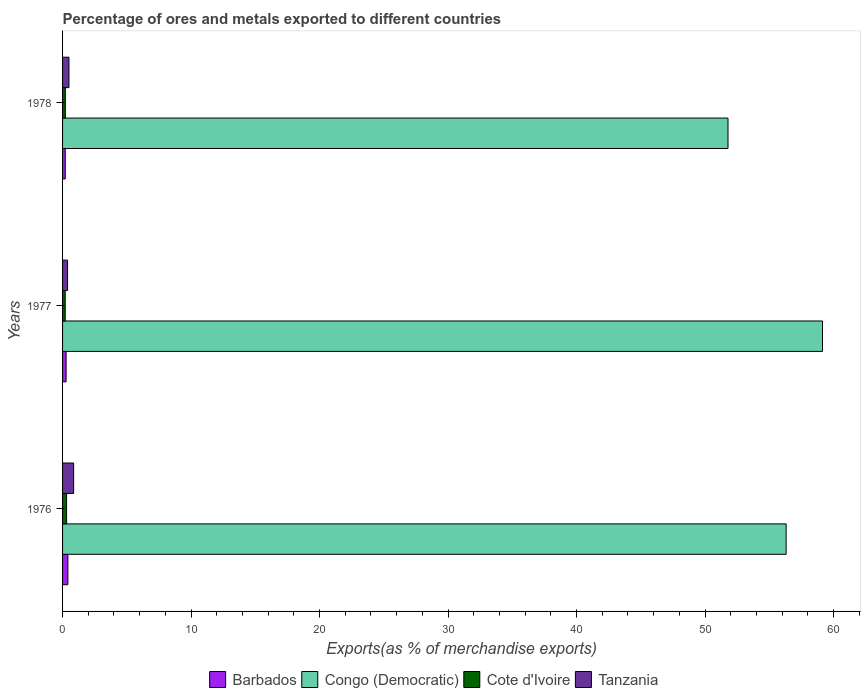How many bars are there on the 2nd tick from the top?
Your response must be concise. 4. How many bars are there on the 1st tick from the bottom?
Your answer should be compact. 4. What is the label of the 3rd group of bars from the top?
Make the answer very short. 1976. What is the percentage of exports to different countries in Barbados in 1978?
Your answer should be very brief. 0.21. Across all years, what is the maximum percentage of exports to different countries in Cote d'Ivoire?
Offer a terse response. 0.31. Across all years, what is the minimum percentage of exports to different countries in Congo (Democratic)?
Your answer should be compact. 51.79. In which year was the percentage of exports to different countries in Barbados maximum?
Keep it short and to the point. 1976. In which year was the percentage of exports to different countries in Barbados minimum?
Ensure brevity in your answer.  1978. What is the total percentage of exports to different countries in Cote d'Ivoire in the graph?
Make the answer very short. 0.74. What is the difference between the percentage of exports to different countries in Barbados in 1977 and that in 1978?
Offer a very short reply. 0.06. What is the difference between the percentage of exports to different countries in Tanzania in 1978 and the percentage of exports to different countries in Barbados in 1976?
Offer a very short reply. 0.09. What is the average percentage of exports to different countries in Cote d'Ivoire per year?
Your answer should be very brief. 0.25. In the year 1978, what is the difference between the percentage of exports to different countries in Cote d'Ivoire and percentage of exports to different countries in Congo (Democratic)?
Your answer should be compact. -51.57. What is the ratio of the percentage of exports to different countries in Cote d'Ivoire in 1977 to that in 1978?
Your response must be concise. 0.95. Is the difference between the percentage of exports to different countries in Cote d'Ivoire in 1976 and 1977 greater than the difference between the percentage of exports to different countries in Congo (Democratic) in 1976 and 1977?
Provide a short and direct response. Yes. What is the difference between the highest and the second highest percentage of exports to different countries in Tanzania?
Your answer should be very brief. 0.36. What is the difference between the highest and the lowest percentage of exports to different countries in Barbados?
Your answer should be very brief. 0.2. In how many years, is the percentage of exports to different countries in Barbados greater than the average percentage of exports to different countries in Barbados taken over all years?
Provide a short and direct response. 1. Is it the case that in every year, the sum of the percentage of exports to different countries in Tanzania and percentage of exports to different countries in Congo (Democratic) is greater than the sum of percentage of exports to different countries in Cote d'Ivoire and percentage of exports to different countries in Barbados?
Provide a short and direct response. No. What does the 3rd bar from the top in 1976 represents?
Offer a very short reply. Congo (Democratic). What does the 4th bar from the bottom in 1976 represents?
Give a very brief answer. Tanzania. Are all the bars in the graph horizontal?
Your response must be concise. Yes. How many years are there in the graph?
Offer a very short reply. 3. What is the difference between two consecutive major ticks on the X-axis?
Make the answer very short. 10. Where does the legend appear in the graph?
Give a very brief answer. Bottom center. How many legend labels are there?
Your answer should be very brief. 4. What is the title of the graph?
Keep it short and to the point. Percentage of ores and metals exported to different countries. Does "Bhutan" appear as one of the legend labels in the graph?
Keep it short and to the point. No. What is the label or title of the X-axis?
Provide a succinct answer. Exports(as % of merchandise exports). What is the label or title of the Y-axis?
Offer a terse response. Years. What is the Exports(as % of merchandise exports) in Barbados in 1976?
Offer a terse response. 0.41. What is the Exports(as % of merchandise exports) of Congo (Democratic) in 1976?
Give a very brief answer. 56.31. What is the Exports(as % of merchandise exports) in Cote d'Ivoire in 1976?
Provide a short and direct response. 0.31. What is the Exports(as % of merchandise exports) in Tanzania in 1976?
Keep it short and to the point. 0.86. What is the Exports(as % of merchandise exports) of Barbados in 1977?
Ensure brevity in your answer.  0.27. What is the Exports(as % of merchandise exports) in Congo (Democratic) in 1977?
Provide a succinct answer. 59.14. What is the Exports(as % of merchandise exports) of Cote d'Ivoire in 1977?
Your response must be concise. 0.21. What is the Exports(as % of merchandise exports) of Tanzania in 1977?
Offer a terse response. 0.39. What is the Exports(as % of merchandise exports) in Barbados in 1978?
Offer a very short reply. 0.21. What is the Exports(as % of merchandise exports) of Congo (Democratic) in 1978?
Give a very brief answer. 51.79. What is the Exports(as % of merchandise exports) of Cote d'Ivoire in 1978?
Ensure brevity in your answer.  0.22. What is the Exports(as % of merchandise exports) of Tanzania in 1978?
Offer a terse response. 0.5. Across all years, what is the maximum Exports(as % of merchandise exports) in Barbados?
Your answer should be compact. 0.41. Across all years, what is the maximum Exports(as % of merchandise exports) in Congo (Democratic)?
Keep it short and to the point. 59.14. Across all years, what is the maximum Exports(as % of merchandise exports) in Cote d'Ivoire?
Provide a short and direct response. 0.31. Across all years, what is the maximum Exports(as % of merchandise exports) in Tanzania?
Provide a short and direct response. 0.86. Across all years, what is the minimum Exports(as % of merchandise exports) in Barbados?
Make the answer very short. 0.21. Across all years, what is the minimum Exports(as % of merchandise exports) of Congo (Democratic)?
Keep it short and to the point. 51.79. Across all years, what is the minimum Exports(as % of merchandise exports) of Cote d'Ivoire?
Your answer should be compact. 0.21. Across all years, what is the minimum Exports(as % of merchandise exports) in Tanzania?
Keep it short and to the point. 0.39. What is the total Exports(as % of merchandise exports) in Barbados in the graph?
Your answer should be compact. 0.9. What is the total Exports(as % of merchandise exports) in Congo (Democratic) in the graph?
Offer a very short reply. 167.24. What is the total Exports(as % of merchandise exports) of Cote d'Ivoire in the graph?
Keep it short and to the point. 0.74. What is the total Exports(as % of merchandise exports) in Tanzania in the graph?
Offer a terse response. 1.75. What is the difference between the Exports(as % of merchandise exports) of Barbados in 1976 and that in 1977?
Offer a very short reply. 0.14. What is the difference between the Exports(as % of merchandise exports) of Congo (Democratic) in 1976 and that in 1977?
Keep it short and to the point. -2.83. What is the difference between the Exports(as % of merchandise exports) of Cote d'Ivoire in 1976 and that in 1977?
Offer a very short reply. 0.11. What is the difference between the Exports(as % of merchandise exports) of Tanzania in 1976 and that in 1977?
Provide a short and direct response. 0.47. What is the difference between the Exports(as % of merchandise exports) of Barbados in 1976 and that in 1978?
Ensure brevity in your answer.  0.2. What is the difference between the Exports(as % of merchandise exports) in Congo (Democratic) in 1976 and that in 1978?
Ensure brevity in your answer.  4.52. What is the difference between the Exports(as % of merchandise exports) of Cote d'Ivoire in 1976 and that in 1978?
Offer a terse response. 0.1. What is the difference between the Exports(as % of merchandise exports) in Tanzania in 1976 and that in 1978?
Your answer should be very brief. 0.36. What is the difference between the Exports(as % of merchandise exports) of Barbados in 1977 and that in 1978?
Make the answer very short. 0.06. What is the difference between the Exports(as % of merchandise exports) in Congo (Democratic) in 1977 and that in 1978?
Keep it short and to the point. 7.35. What is the difference between the Exports(as % of merchandise exports) in Cote d'Ivoire in 1977 and that in 1978?
Your answer should be compact. -0.01. What is the difference between the Exports(as % of merchandise exports) in Tanzania in 1977 and that in 1978?
Offer a very short reply. -0.11. What is the difference between the Exports(as % of merchandise exports) in Barbados in 1976 and the Exports(as % of merchandise exports) in Congo (Democratic) in 1977?
Give a very brief answer. -58.73. What is the difference between the Exports(as % of merchandise exports) in Barbados in 1976 and the Exports(as % of merchandise exports) in Cote d'Ivoire in 1977?
Give a very brief answer. 0.21. What is the difference between the Exports(as % of merchandise exports) in Barbados in 1976 and the Exports(as % of merchandise exports) in Tanzania in 1977?
Your answer should be compact. 0.02. What is the difference between the Exports(as % of merchandise exports) in Congo (Democratic) in 1976 and the Exports(as % of merchandise exports) in Cote d'Ivoire in 1977?
Offer a very short reply. 56.11. What is the difference between the Exports(as % of merchandise exports) of Congo (Democratic) in 1976 and the Exports(as % of merchandise exports) of Tanzania in 1977?
Your answer should be compact. 55.92. What is the difference between the Exports(as % of merchandise exports) in Cote d'Ivoire in 1976 and the Exports(as % of merchandise exports) in Tanzania in 1977?
Your answer should be very brief. -0.08. What is the difference between the Exports(as % of merchandise exports) in Barbados in 1976 and the Exports(as % of merchandise exports) in Congo (Democratic) in 1978?
Ensure brevity in your answer.  -51.37. What is the difference between the Exports(as % of merchandise exports) of Barbados in 1976 and the Exports(as % of merchandise exports) of Cote d'Ivoire in 1978?
Give a very brief answer. 0.2. What is the difference between the Exports(as % of merchandise exports) of Barbados in 1976 and the Exports(as % of merchandise exports) of Tanzania in 1978?
Your answer should be compact. -0.09. What is the difference between the Exports(as % of merchandise exports) of Congo (Democratic) in 1976 and the Exports(as % of merchandise exports) of Cote d'Ivoire in 1978?
Provide a succinct answer. 56.1. What is the difference between the Exports(as % of merchandise exports) in Congo (Democratic) in 1976 and the Exports(as % of merchandise exports) in Tanzania in 1978?
Provide a succinct answer. 55.81. What is the difference between the Exports(as % of merchandise exports) of Cote d'Ivoire in 1976 and the Exports(as % of merchandise exports) of Tanzania in 1978?
Offer a terse response. -0.18. What is the difference between the Exports(as % of merchandise exports) of Barbados in 1977 and the Exports(as % of merchandise exports) of Congo (Democratic) in 1978?
Your answer should be compact. -51.51. What is the difference between the Exports(as % of merchandise exports) in Barbados in 1977 and the Exports(as % of merchandise exports) in Cote d'Ivoire in 1978?
Your response must be concise. 0.06. What is the difference between the Exports(as % of merchandise exports) in Barbados in 1977 and the Exports(as % of merchandise exports) in Tanzania in 1978?
Your response must be concise. -0.22. What is the difference between the Exports(as % of merchandise exports) of Congo (Democratic) in 1977 and the Exports(as % of merchandise exports) of Cote d'Ivoire in 1978?
Provide a short and direct response. 58.92. What is the difference between the Exports(as % of merchandise exports) in Congo (Democratic) in 1977 and the Exports(as % of merchandise exports) in Tanzania in 1978?
Make the answer very short. 58.64. What is the difference between the Exports(as % of merchandise exports) of Cote d'Ivoire in 1977 and the Exports(as % of merchandise exports) of Tanzania in 1978?
Provide a succinct answer. -0.29. What is the average Exports(as % of merchandise exports) in Barbados per year?
Ensure brevity in your answer.  0.3. What is the average Exports(as % of merchandise exports) in Congo (Democratic) per year?
Make the answer very short. 55.75. What is the average Exports(as % of merchandise exports) in Cote d'Ivoire per year?
Offer a terse response. 0.25. What is the average Exports(as % of merchandise exports) of Tanzania per year?
Offer a very short reply. 0.58. In the year 1976, what is the difference between the Exports(as % of merchandise exports) in Barbados and Exports(as % of merchandise exports) in Congo (Democratic)?
Your answer should be compact. -55.9. In the year 1976, what is the difference between the Exports(as % of merchandise exports) in Barbados and Exports(as % of merchandise exports) in Cote d'Ivoire?
Your response must be concise. 0.1. In the year 1976, what is the difference between the Exports(as % of merchandise exports) in Barbados and Exports(as % of merchandise exports) in Tanzania?
Give a very brief answer. -0.45. In the year 1976, what is the difference between the Exports(as % of merchandise exports) in Congo (Democratic) and Exports(as % of merchandise exports) in Cote d'Ivoire?
Your answer should be compact. 56. In the year 1976, what is the difference between the Exports(as % of merchandise exports) in Congo (Democratic) and Exports(as % of merchandise exports) in Tanzania?
Give a very brief answer. 55.45. In the year 1976, what is the difference between the Exports(as % of merchandise exports) in Cote d'Ivoire and Exports(as % of merchandise exports) in Tanzania?
Provide a short and direct response. -0.55. In the year 1977, what is the difference between the Exports(as % of merchandise exports) in Barbados and Exports(as % of merchandise exports) in Congo (Democratic)?
Your response must be concise. -58.87. In the year 1977, what is the difference between the Exports(as % of merchandise exports) of Barbados and Exports(as % of merchandise exports) of Cote d'Ivoire?
Your answer should be very brief. 0.07. In the year 1977, what is the difference between the Exports(as % of merchandise exports) of Barbados and Exports(as % of merchandise exports) of Tanzania?
Keep it short and to the point. -0.11. In the year 1977, what is the difference between the Exports(as % of merchandise exports) of Congo (Democratic) and Exports(as % of merchandise exports) of Cote d'Ivoire?
Your answer should be very brief. 58.94. In the year 1977, what is the difference between the Exports(as % of merchandise exports) of Congo (Democratic) and Exports(as % of merchandise exports) of Tanzania?
Keep it short and to the point. 58.75. In the year 1977, what is the difference between the Exports(as % of merchandise exports) in Cote d'Ivoire and Exports(as % of merchandise exports) in Tanzania?
Keep it short and to the point. -0.18. In the year 1978, what is the difference between the Exports(as % of merchandise exports) in Barbados and Exports(as % of merchandise exports) in Congo (Democratic)?
Make the answer very short. -51.58. In the year 1978, what is the difference between the Exports(as % of merchandise exports) in Barbados and Exports(as % of merchandise exports) in Cote d'Ivoire?
Provide a succinct answer. -0.01. In the year 1978, what is the difference between the Exports(as % of merchandise exports) of Barbados and Exports(as % of merchandise exports) of Tanzania?
Keep it short and to the point. -0.29. In the year 1978, what is the difference between the Exports(as % of merchandise exports) of Congo (Democratic) and Exports(as % of merchandise exports) of Cote d'Ivoire?
Provide a succinct answer. 51.57. In the year 1978, what is the difference between the Exports(as % of merchandise exports) in Congo (Democratic) and Exports(as % of merchandise exports) in Tanzania?
Your response must be concise. 51.29. In the year 1978, what is the difference between the Exports(as % of merchandise exports) of Cote d'Ivoire and Exports(as % of merchandise exports) of Tanzania?
Offer a very short reply. -0.28. What is the ratio of the Exports(as % of merchandise exports) of Barbados in 1976 to that in 1977?
Your answer should be very brief. 1.5. What is the ratio of the Exports(as % of merchandise exports) of Congo (Democratic) in 1976 to that in 1977?
Offer a very short reply. 0.95. What is the ratio of the Exports(as % of merchandise exports) in Cote d'Ivoire in 1976 to that in 1977?
Provide a succinct answer. 1.52. What is the ratio of the Exports(as % of merchandise exports) of Tanzania in 1976 to that in 1977?
Offer a very short reply. 2.22. What is the ratio of the Exports(as % of merchandise exports) of Barbados in 1976 to that in 1978?
Ensure brevity in your answer.  1.97. What is the ratio of the Exports(as % of merchandise exports) of Congo (Democratic) in 1976 to that in 1978?
Offer a very short reply. 1.09. What is the ratio of the Exports(as % of merchandise exports) in Cote d'Ivoire in 1976 to that in 1978?
Your answer should be very brief. 1.45. What is the ratio of the Exports(as % of merchandise exports) in Tanzania in 1976 to that in 1978?
Offer a very short reply. 1.73. What is the ratio of the Exports(as % of merchandise exports) of Barbados in 1977 to that in 1978?
Offer a terse response. 1.31. What is the ratio of the Exports(as % of merchandise exports) of Congo (Democratic) in 1977 to that in 1978?
Your answer should be very brief. 1.14. What is the ratio of the Exports(as % of merchandise exports) in Cote d'Ivoire in 1977 to that in 1978?
Keep it short and to the point. 0.95. What is the ratio of the Exports(as % of merchandise exports) in Tanzania in 1977 to that in 1978?
Your answer should be compact. 0.78. What is the difference between the highest and the second highest Exports(as % of merchandise exports) in Barbados?
Offer a very short reply. 0.14. What is the difference between the highest and the second highest Exports(as % of merchandise exports) of Congo (Democratic)?
Give a very brief answer. 2.83. What is the difference between the highest and the second highest Exports(as % of merchandise exports) in Cote d'Ivoire?
Offer a very short reply. 0.1. What is the difference between the highest and the second highest Exports(as % of merchandise exports) in Tanzania?
Keep it short and to the point. 0.36. What is the difference between the highest and the lowest Exports(as % of merchandise exports) in Barbados?
Your answer should be very brief. 0.2. What is the difference between the highest and the lowest Exports(as % of merchandise exports) in Congo (Democratic)?
Offer a terse response. 7.35. What is the difference between the highest and the lowest Exports(as % of merchandise exports) of Cote d'Ivoire?
Offer a terse response. 0.11. What is the difference between the highest and the lowest Exports(as % of merchandise exports) of Tanzania?
Your response must be concise. 0.47. 